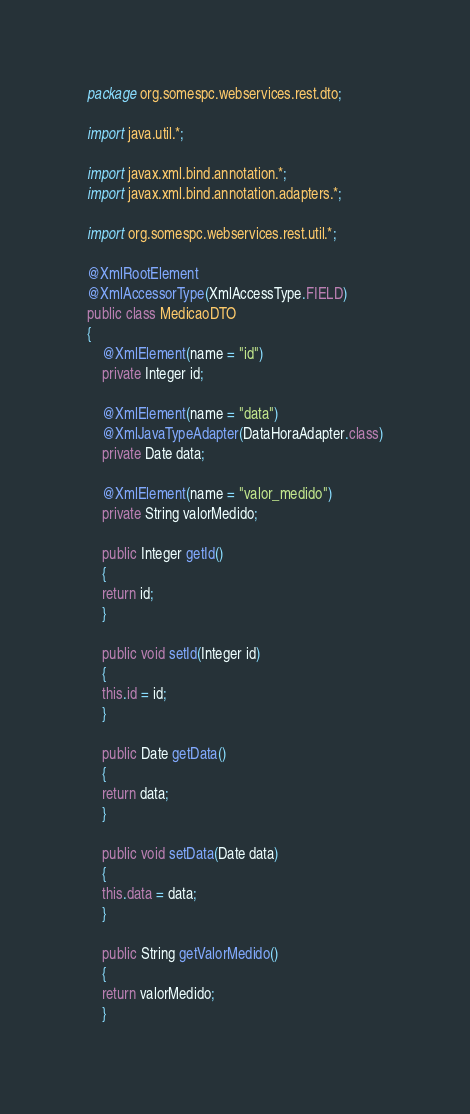Convert code to text. <code><loc_0><loc_0><loc_500><loc_500><_Java_>package org.somespc.webservices.rest.dto;

import java.util.*;

import javax.xml.bind.annotation.*;
import javax.xml.bind.annotation.adapters.*;

import org.somespc.webservices.rest.util.*;

@XmlRootElement
@XmlAccessorType(XmlAccessType.FIELD)
public class MedicaoDTO
{
    @XmlElement(name = "id")
    private Integer id;

    @XmlElement(name = "data")
    @XmlJavaTypeAdapter(DataHoraAdapter.class)
    private Date data;

    @XmlElement(name = "valor_medido")
    private String valorMedido;

    public Integer getId()
    {
	return id;
    }

    public void setId(Integer id)
    {
	this.id = id;
    }

    public Date getData()
    {
	return data;
    }

    public void setData(Date data)
    {
	this.data = data;
    }

    public String getValorMedido()
    {
	return valorMedido;
    }
</code> 